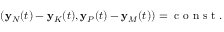<formula> <loc_0><loc_0><loc_500><loc_500>\begin{array} { r } { ( { y } _ { N } ( t ) - { y } _ { K } ( t ) , { y } _ { P } ( t ) - { y } _ { M } ( t ) ) = c o n s t . } \end{array}</formula> 